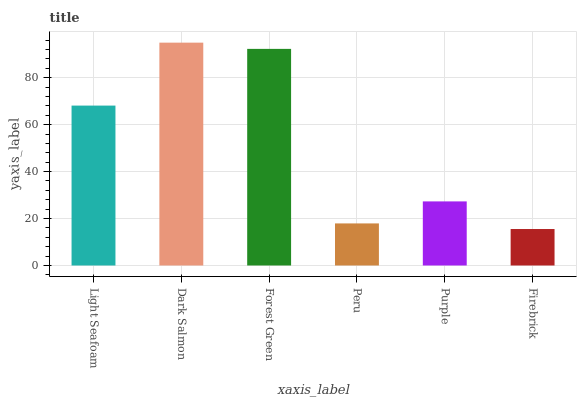Is Forest Green the minimum?
Answer yes or no. No. Is Forest Green the maximum?
Answer yes or no. No. Is Dark Salmon greater than Forest Green?
Answer yes or no. Yes. Is Forest Green less than Dark Salmon?
Answer yes or no. Yes. Is Forest Green greater than Dark Salmon?
Answer yes or no. No. Is Dark Salmon less than Forest Green?
Answer yes or no. No. Is Light Seafoam the high median?
Answer yes or no. Yes. Is Purple the low median?
Answer yes or no. Yes. Is Firebrick the high median?
Answer yes or no. No. Is Forest Green the low median?
Answer yes or no. No. 